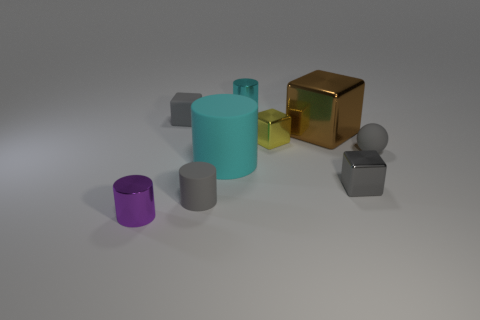Subtract all gray cubes. How many were subtracted if there are1gray cubes left? 1 Subtract all yellow cylinders. Subtract all blue cubes. How many cylinders are left? 4 Add 1 cyan shiny objects. How many objects exist? 10 Subtract all spheres. How many objects are left? 8 Subtract all blocks. Subtract all small metallic cylinders. How many objects are left? 3 Add 2 tiny gray cylinders. How many tiny gray cylinders are left? 3 Add 9 big spheres. How many big spheres exist? 9 Subtract 0 red spheres. How many objects are left? 9 